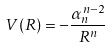Convert formula to latex. <formula><loc_0><loc_0><loc_500><loc_500>V ( R ) = - \frac { \alpha _ { n } ^ { n - 2 } } { R ^ { n } }</formula> 